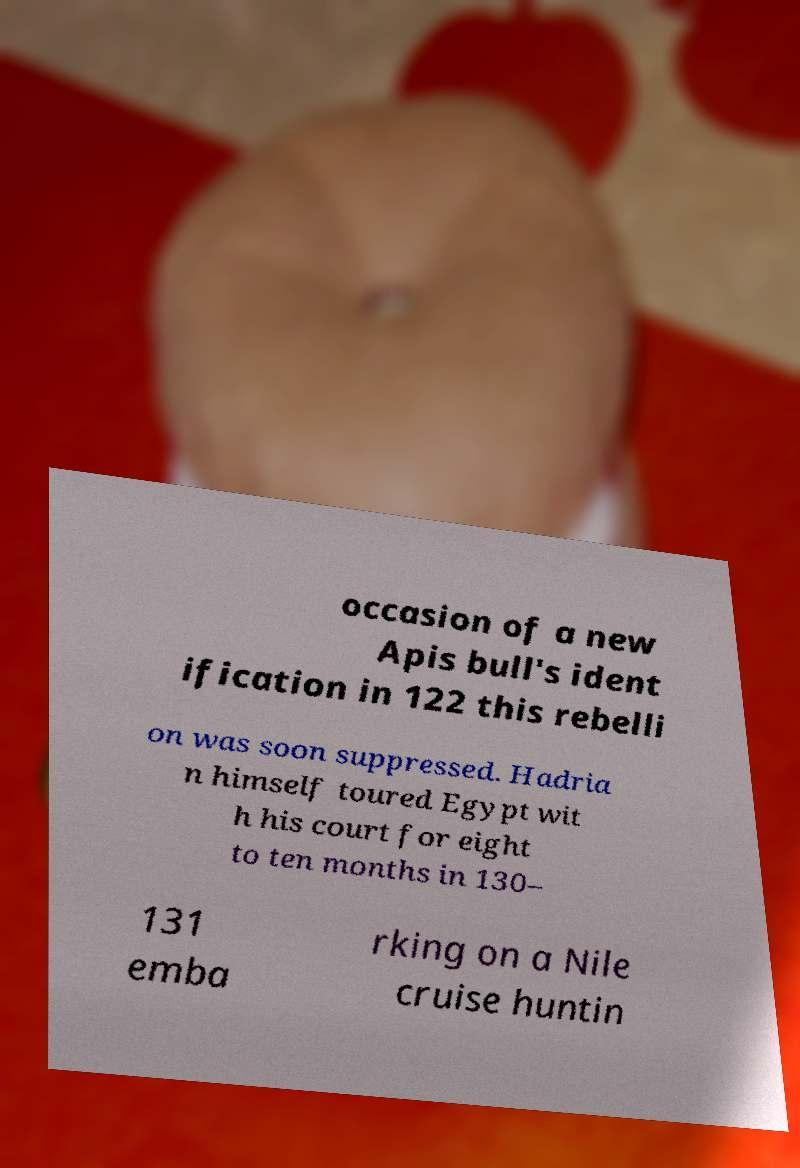Can you accurately transcribe the text from the provided image for me? occasion of a new Apis bull's ident ification in 122 this rebelli on was soon suppressed. Hadria n himself toured Egypt wit h his court for eight to ten months in 130– 131 emba rking on a Nile cruise huntin 